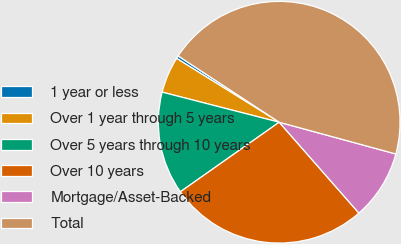<chart> <loc_0><loc_0><loc_500><loc_500><pie_chart><fcel>1 year or less<fcel>Over 1 year through 5 years<fcel>Over 5 years through 10 years<fcel>Over 10 years<fcel>Mortgage/Asset-Backed<fcel>Total<nl><fcel>0.39%<fcel>4.85%<fcel>13.77%<fcel>26.7%<fcel>9.31%<fcel>44.99%<nl></chart> 